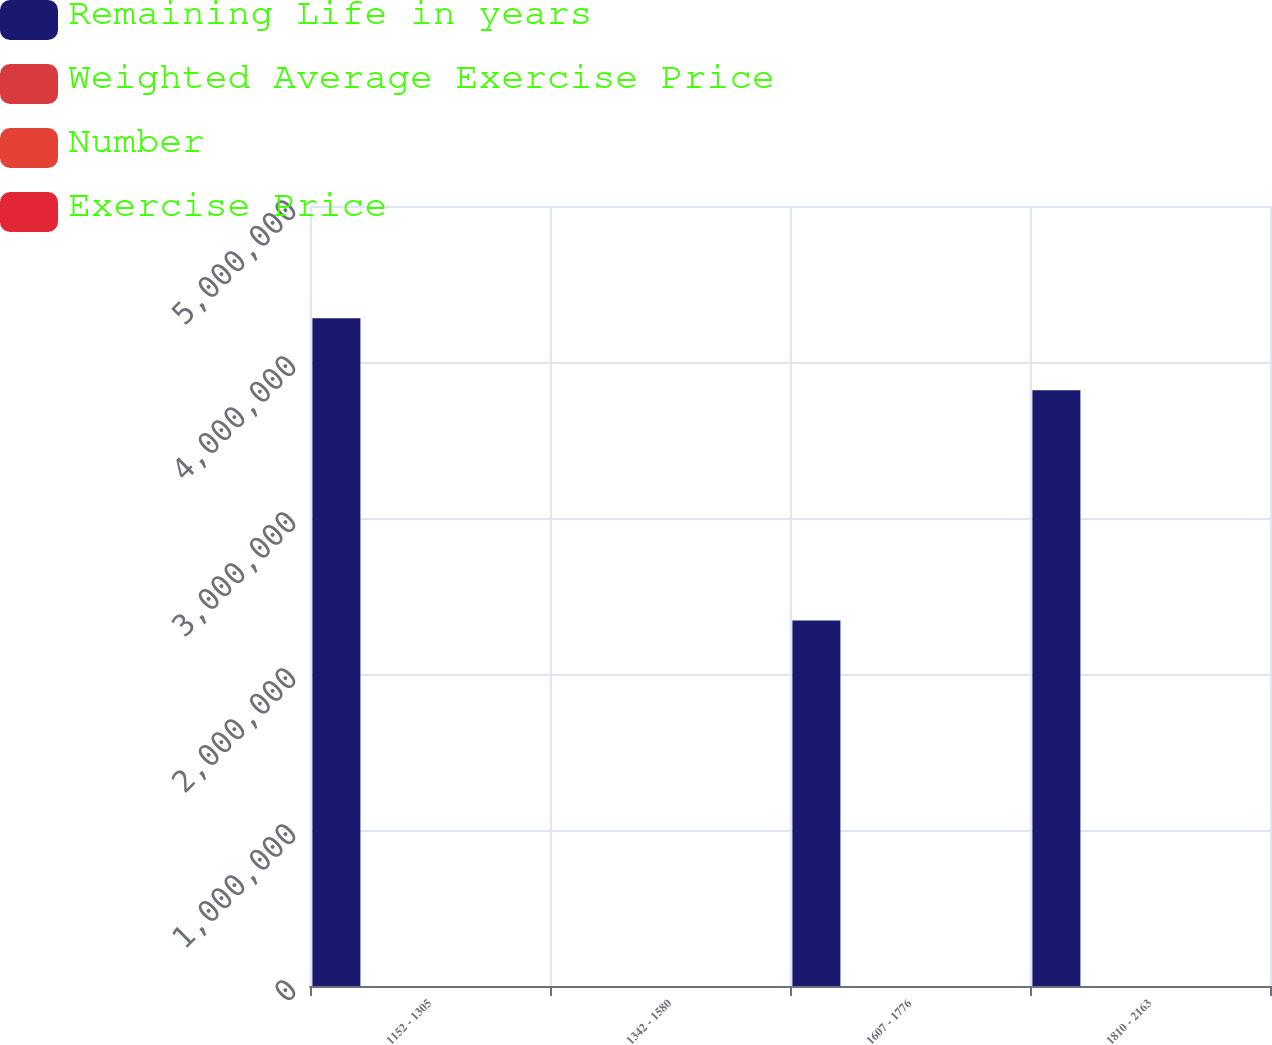Convert chart. <chart><loc_0><loc_0><loc_500><loc_500><stacked_bar_chart><ecel><fcel>1152 - 1305<fcel>1342 - 1580<fcel>1607 - 1776<fcel>1810 - 2163<nl><fcel>Remaining Life in years<fcel>4.28005e+06<fcel>14.91<fcel>2.34248e+06<fcel>3.81828e+06<nl><fcel>Weighted Average Exercise Price<fcel>7.1<fcel>7.5<fcel>3.3<fcel>2.4<nl><fcel>Number<fcel>12.78<fcel>14.23<fcel>16.95<fcel>18.28<nl><fcel>Exercise Price<fcel>12.7<fcel>14.91<fcel>16.95<fcel>18.28<nl></chart> 